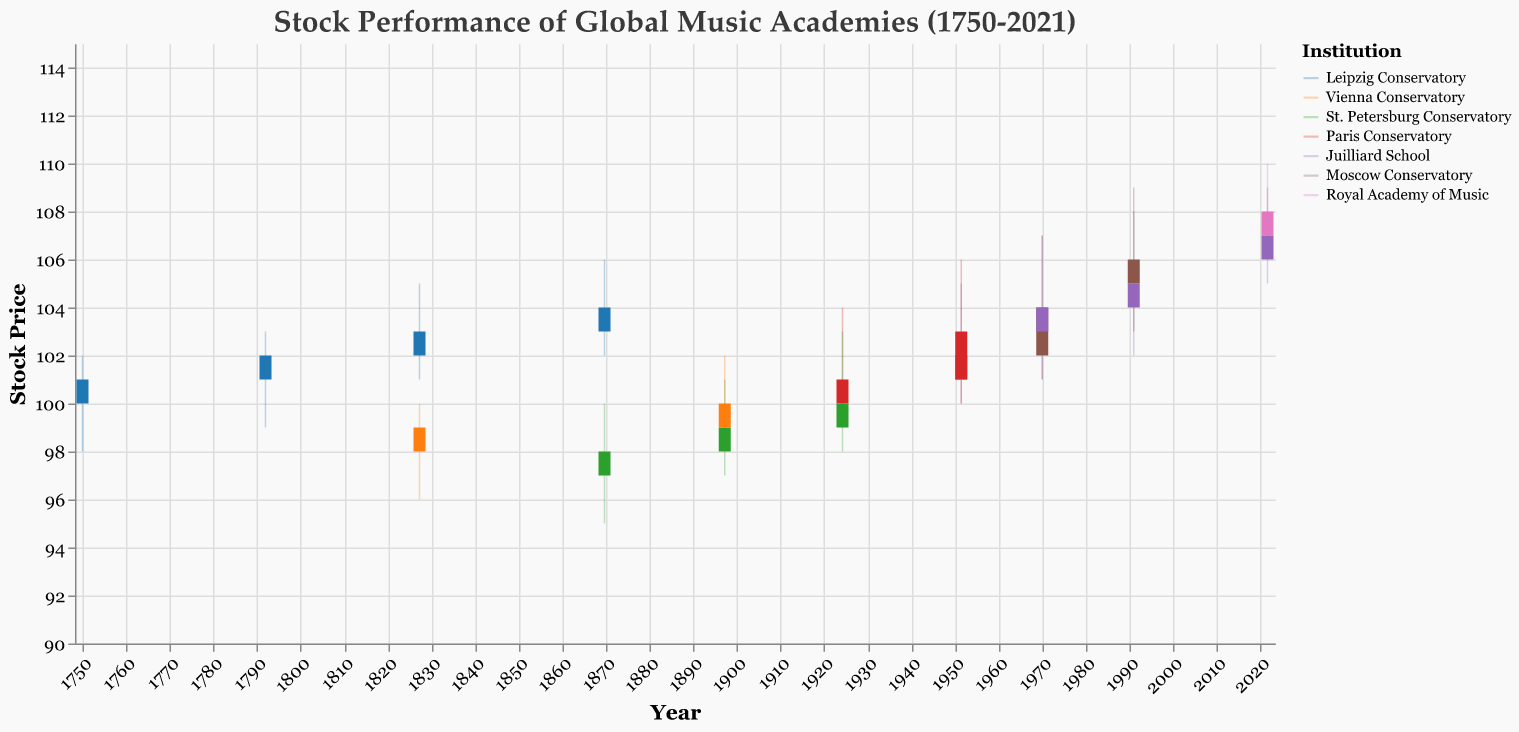What's the title of the figure? The title of the figure is displayed at the top and usually gives a clear description of what the plot is about. In this case, the title reads "Stock Performance of Global Music Academies (1750-2021)".
Answer: Stock Performance of Global Music Academies (1750-2021) Which institution had the highest stock price in 2021? Look at the data points for the year 2021 and compare the "High" values for each institution. The institutions present in 2021 are Juilliard School and Royal Academy of Music. The Royal Academy of Music had the highest stock price at 110.
Answer: Royal Academy of Music What is the average closing stock price of Juilliard School on the given dates? Find all the closing prices for Juilliard School and then calculate their average. The closing prices are 102 (1951), 104 (1970), 105 (1990), and 107 (2021). Average = (102 + 104 + 105 + 107) / 4 = 104.5
Answer: 104.5 Compare the opening stock prices of Leipzig Conservatory in 1750 and 1869. Which one is higher? Check the "Open" values for Leipzig Conservatory in the years 1750 and 1869. The values are 100 (1750) and 103 (1869). So, 103 is higher than 100.
Answer: 1869 Between which two institutions did the most noticeable increase in the stock price occur between their respective historical data points? Compare the closing prices of each institution across the available dates. The most noticeable increase is between the Leipzig Conservatory from 1750 (101) to 1869 (104), and the Juilliard School from 1951 (102) to 2021 (107). Noticeable means a larger absolute change: Leipzig increased by 3 units and Juilliard by 5 units. Hence, Juilliard School had the most noticeable increase.
Answer: Juilliard School 